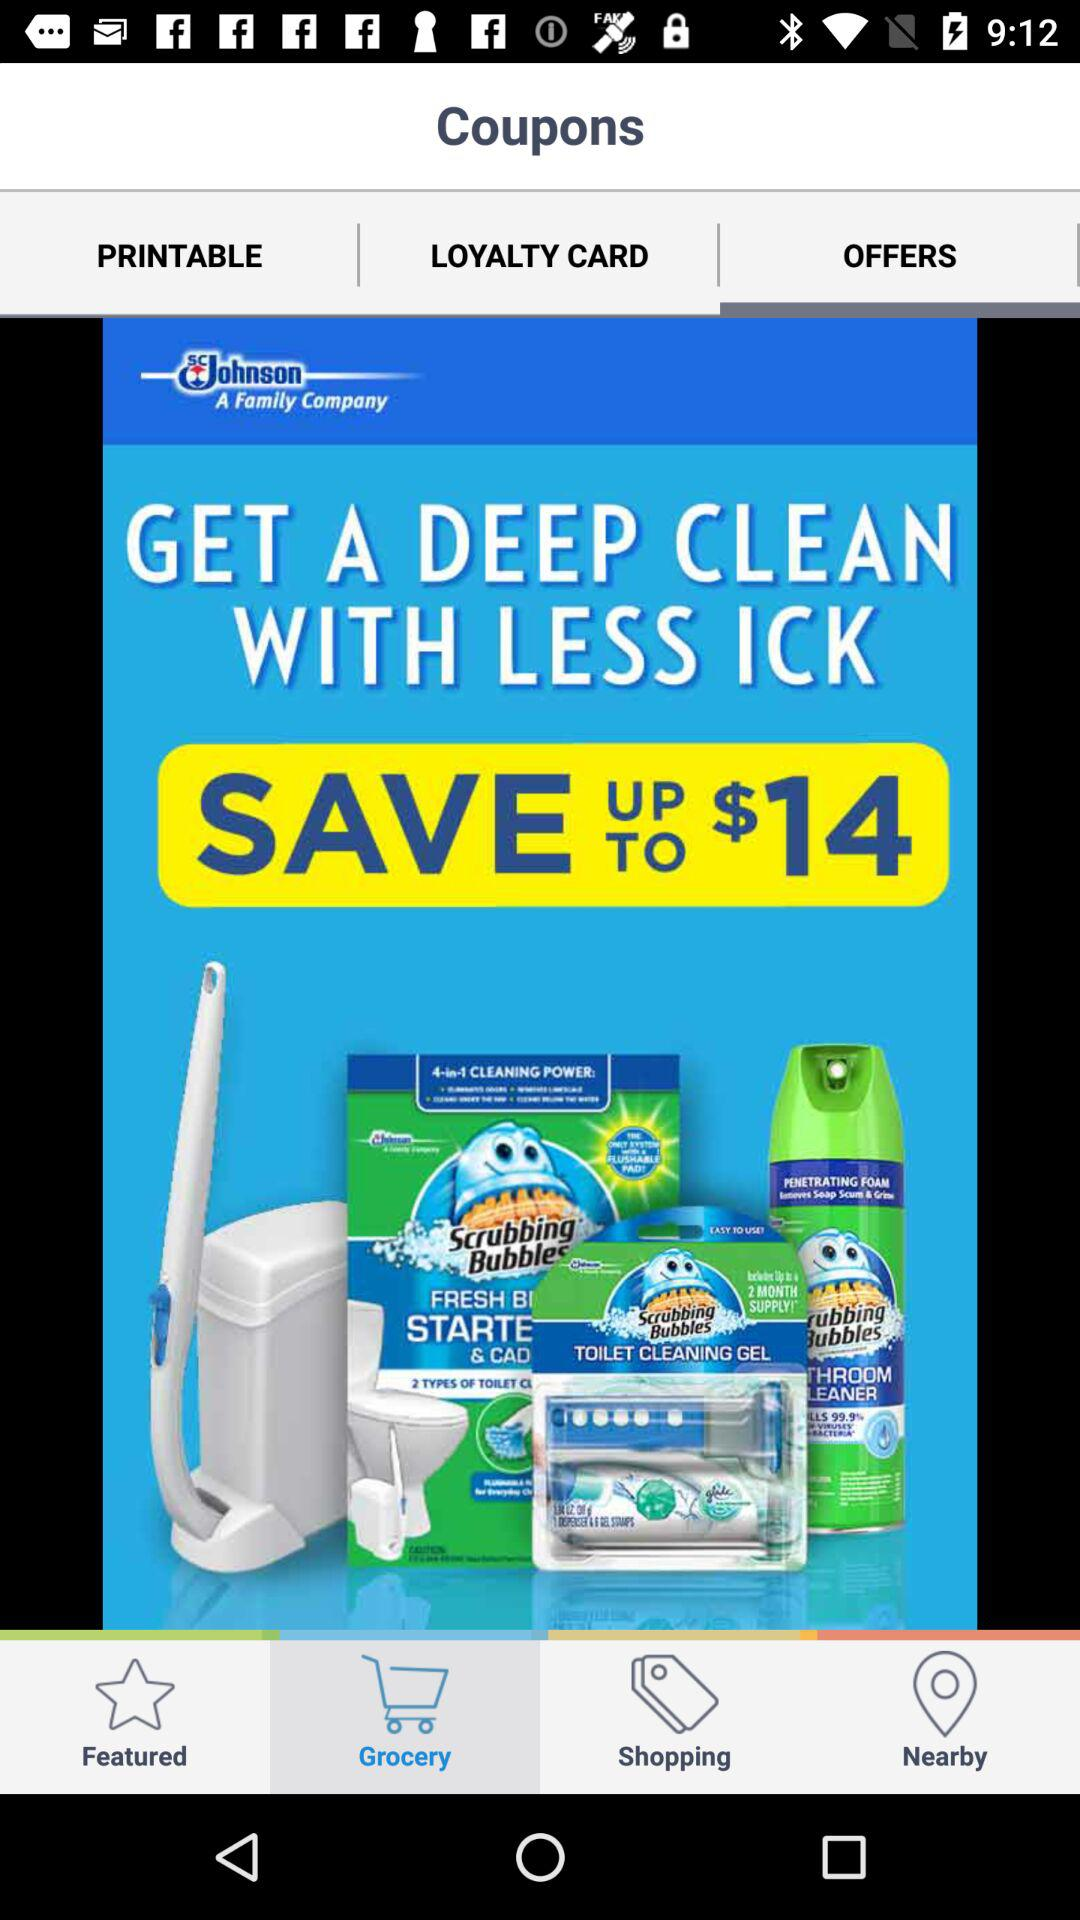Which tab has been selected? The selected tab is "Grocery". 